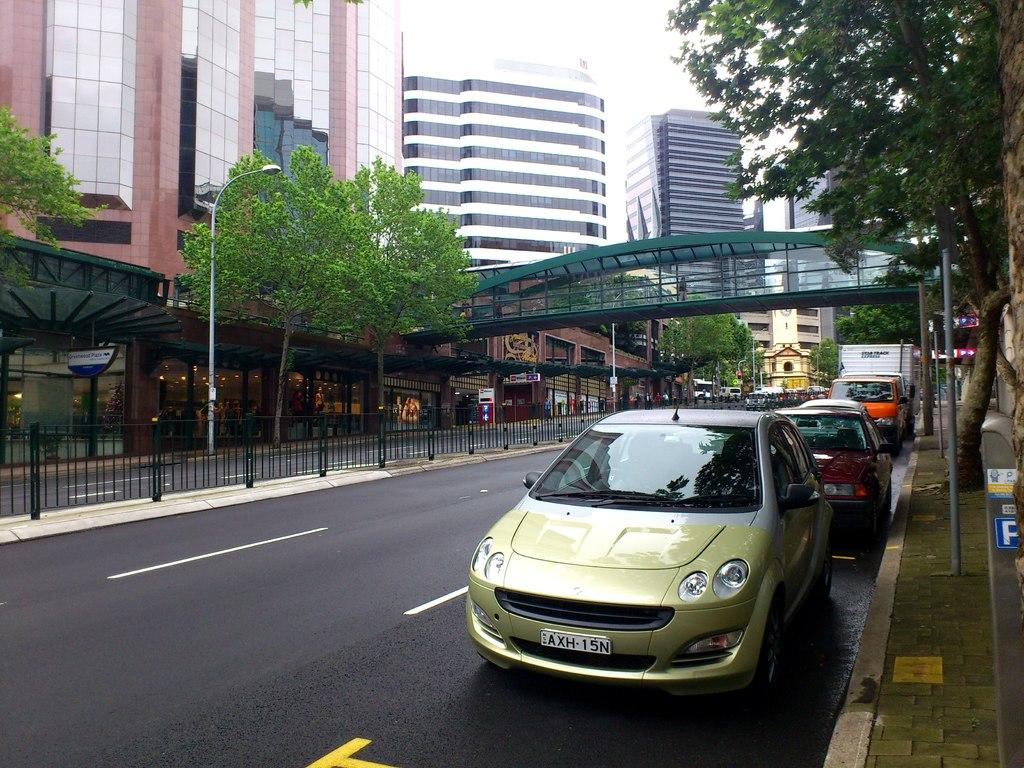What can be seen on the road in the image? There are vehicles on the road in the image. What structure is present near the road? There is a light pole in the image. What objects are visible in the image that might be used for displaying information or advertisements? There are boards and poles in the image. What safety feature is present in the image? There is a railing in the image. What type of vegetation is visible in the image? There are trees in the image. What type of man-made structures can be seen in the image? There are buildings in the image. What type of infrastructure is present in the image? There is a bridge in the image. What is visible in the background of the image? The sky is visible in the background of the image. How many horses are visible on the bridge in the image? There are no horses present in the image. What type of rat can be seen running along the railing in the image? There are no rats present in the image. 